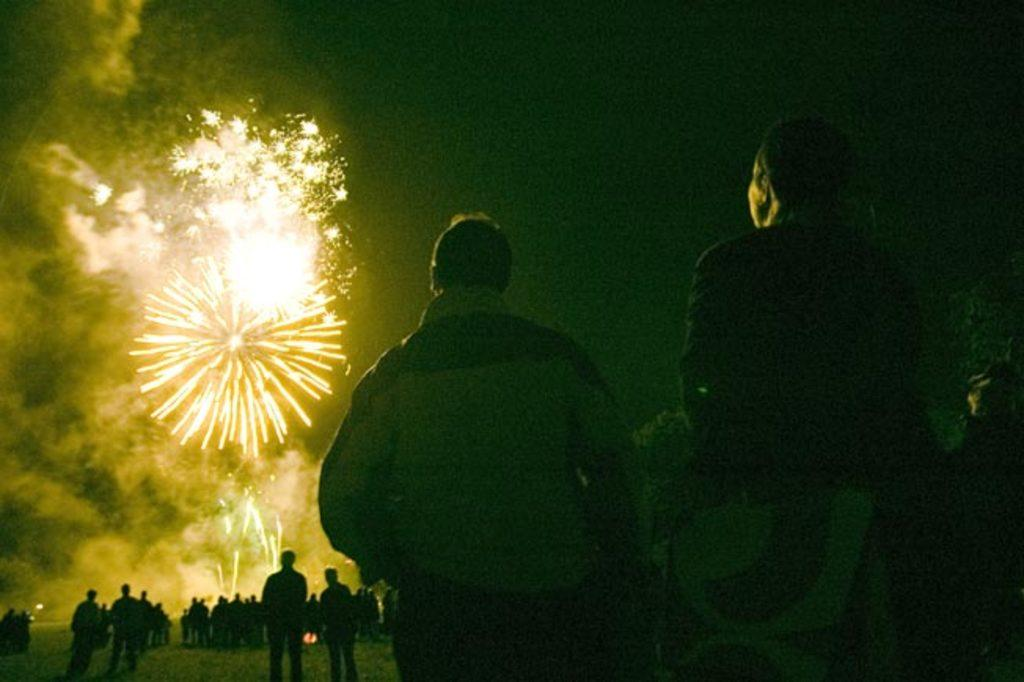Who or what is present in the image? There are people in the image. What can be seen in the background of the image? There is smoke, sparkles, and the sky visible in the background of the image. Where is the scarecrow located in the image? There is no scarecrow present in the image. What is the facial expression of the people in the image? The provided facts do not mention the facial expressions of the people in the image. 